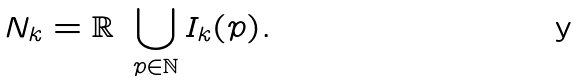<formula> <loc_0><loc_0><loc_500><loc_500>N _ { k } = \mathbb { R } \ \bigcup _ { p \in \mathbb { N } } I _ { k } ( p ) .</formula> 